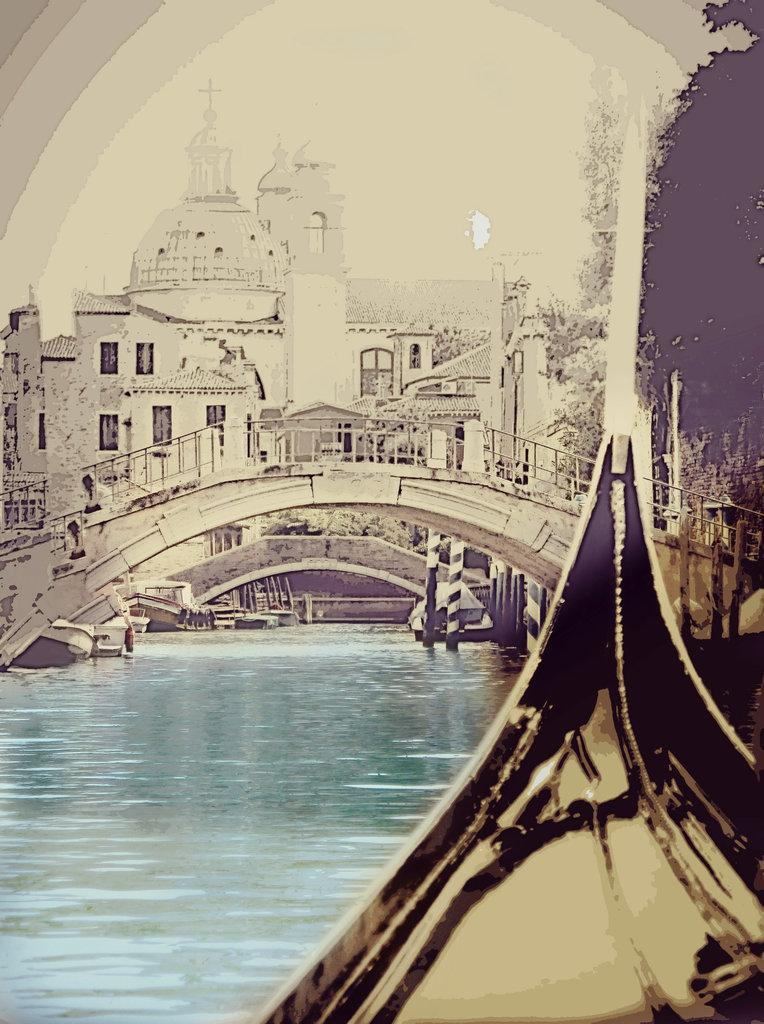What is the main structure in the center of the image? There is a foot over bridge in the center of the image. What is the foot over bridge positioned above? The foot over bridge is above a lake. What can be seen in the background of the image? There are buildings and poles in the background of the image, as well as the sky. What is located at the bottom of the image? There is a boat at the bottom of the image. How many eyes does the foot over bridge have in the image? The foot over bridge does not have eyes; it is an inanimate structure. 